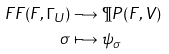Convert formula to latex. <formula><loc_0><loc_0><loc_500><loc_500>\ F F ( F , \Gamma _ { \, U } ) & \longrightarrow \P P ( F , V ) \\ \sigma & \longmapsto \psi _ { \sigma }</formula> 